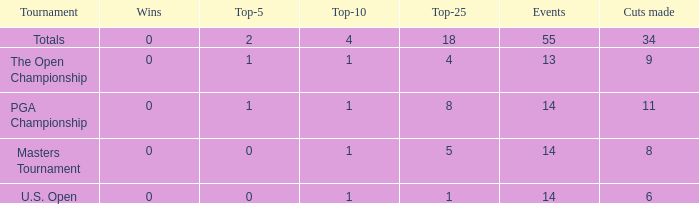What is the average top-5 when the cuts made is more than 34? None. 